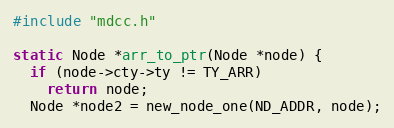<code> <loc_0><loc_0><loc_500><loc_500><_C_>#include "mdcc.h"

static Node *arr_to_ptr(Node *node) {
  if (node->cty->ty != TY_ARR)
    return node;
  Node *node2 = new_node_one(ND_ADDR, node);</code> 